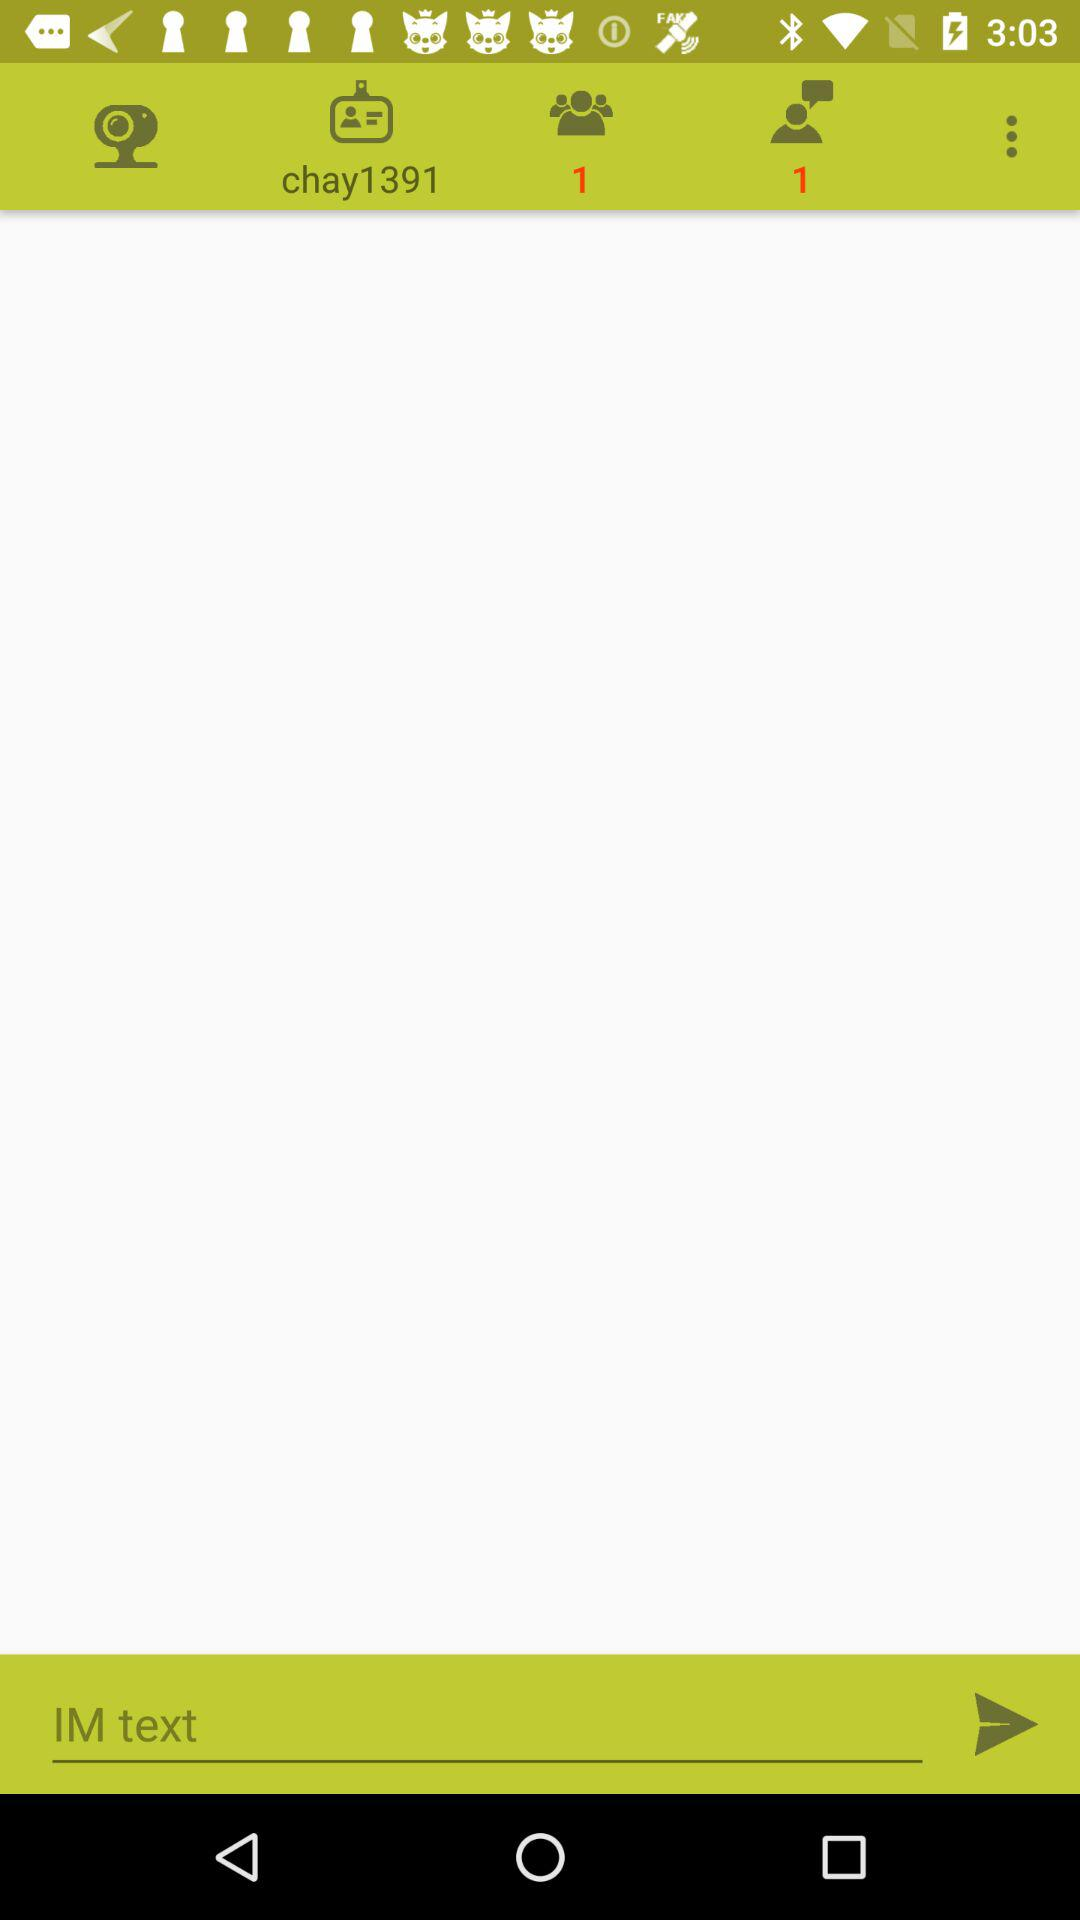What is the username? The username is "chay1391". 